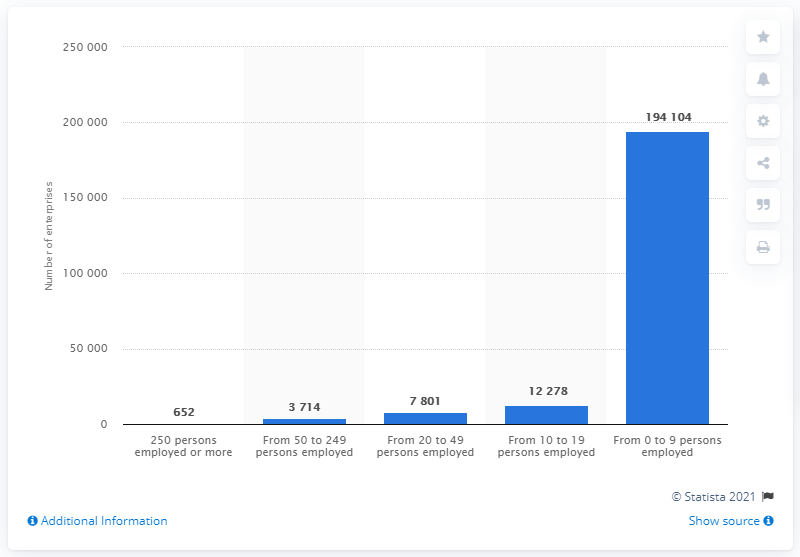Indicate a few pertinent items in this graphic. In 2016, there were 652 enterprises in Denmark that had 250 or more employees. 